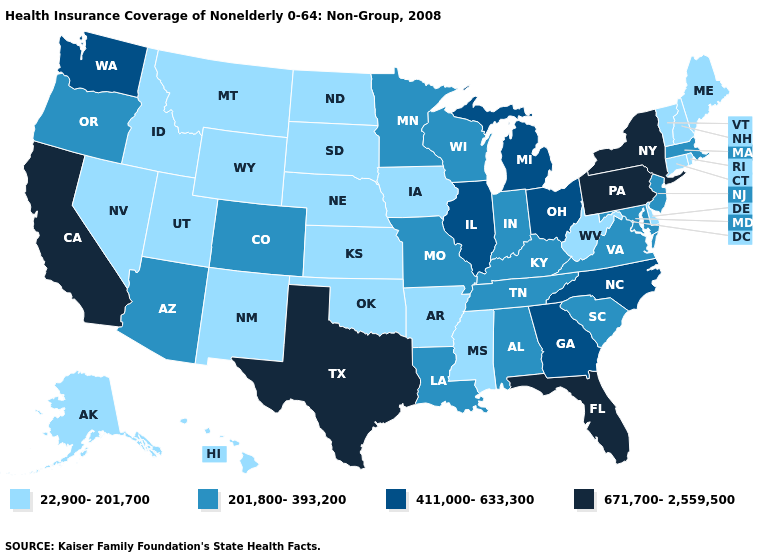How many symbols are there in the legend?
Give a very brief answer. 4. Name the states that have a value in the range 671,700-2,559,500?
Be succinct. California, Florida, New York, Pennsylvania, Texas. What is the value of Hawaii?
Write a very short answer. 22,900-201,700. Among the states that border Georgia , does Florida have the lowest value?
Give a very brief answer. No. Name the states that have a value in the range 671,700-2,559,500?
Quick response, please. California, Florida, New York, Pennsylvania, Texas. Which states have the lowest value in the USA?
Keep it brief. Alaska, Arkansas, Connecticut, Delaware, Hawaii, Idaho, Iowa, Kansas, Maine, Mississippi, Montana, Nebraska, Nevada, New Hampshire, New Mexico, North Dakota, Oklahoma, Rhode Island, South Dakota, Utah, Vermont, West Virginia, Wyoming. Which states have the lowest value in the Northeast?
Be succinct. Connecticut, Maine, New Hampshire, Rhode Island, Vermont. Among the states that border Nebraska , does Colorado have the lowest value?
Quick response, please. No. Among the states that border Virginia , which have the lowest value?
Quick response, please. West Virginia. What is the lowest value in states that border Missouri?
Answer briefly. 22,900-201,700. What is the value of Florida?
Short answer required. 671,700-2,559,500. Name the states that have a value in the range 22,900-201,700?
Concise answer only. Alaska, Arkansas, Connecticut, Delaware, Hawaii, Idaho, Iowa, Kansas, Maine, Mississippi, Montana, Nebraska, Nevada, New Hampshire, New Mexico, North Dakota, Oklahoma, Rhode Island, South Dakota, Utah, Vermont, West Virginia, Wyoming. Name the states that have a value in the range 411,000-633,300?
Concise answer only. Georgia, Illinois, Michigan, North Carolina, Ohio, Washington. Name the states that have a value in the range 671,700-2,559,500?
Quick response, please. California, Florida, New York, Pennsylvania, Texas. Does Indiana have the highest value in the MidWest?
Be succinct. No. 